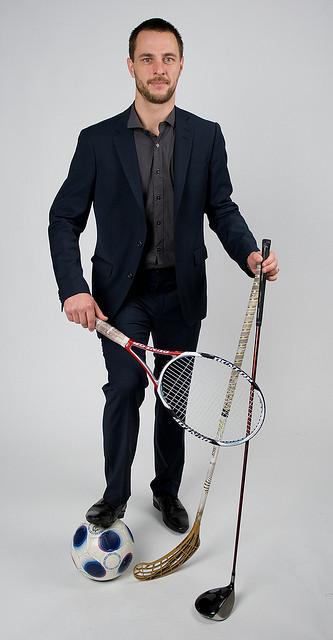Would someone typically use all these together?
Short answer required. No. How many different types of sports equipment is he holding?
Answer briefly. 4. Is the athlete skiing or snowboarding?
Write a very short answer. Neither. Can he fly on his own?
Short answer required. No. 